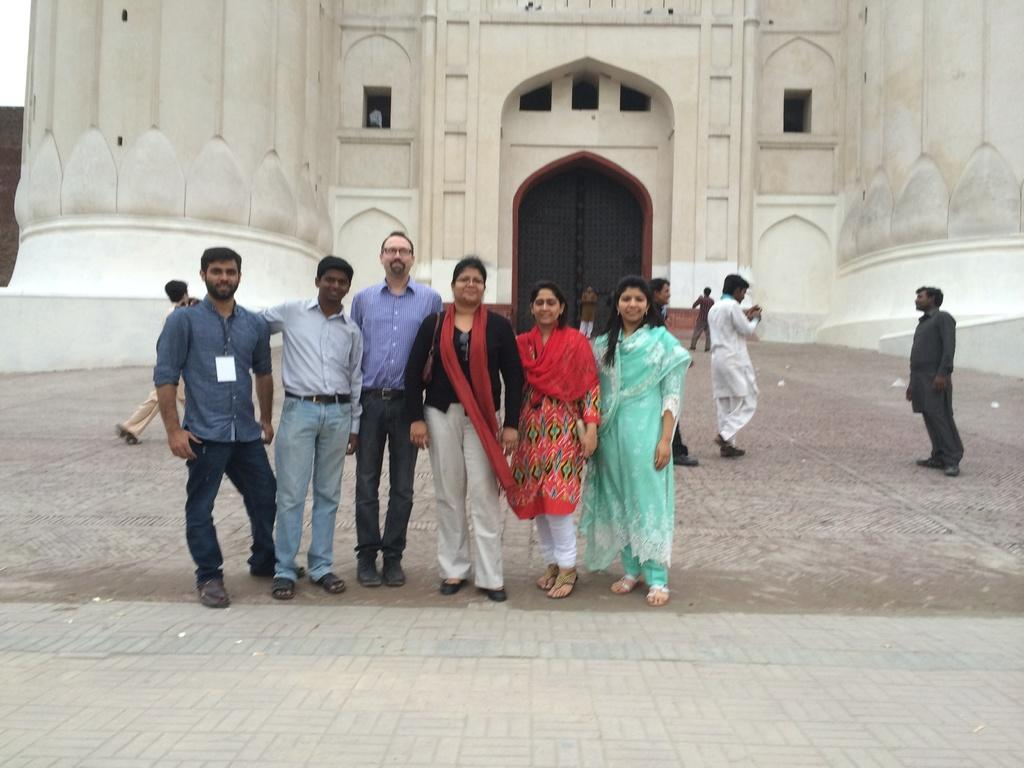How many people are in the image? There is a group of people in the image, but the exact number is not specified. What are the people in the image doing? Some people are standing, while others are walking. What is located at the bottom of the image? There is a platform at the bottom of the image. What can be seen in the background of the image? In the background, there is a fort with walls and doors. How many fingers does the person in the image have? The number of fingers a person has cannot be determined from the image, as it does not show a close-up of anyone's hands. --- 